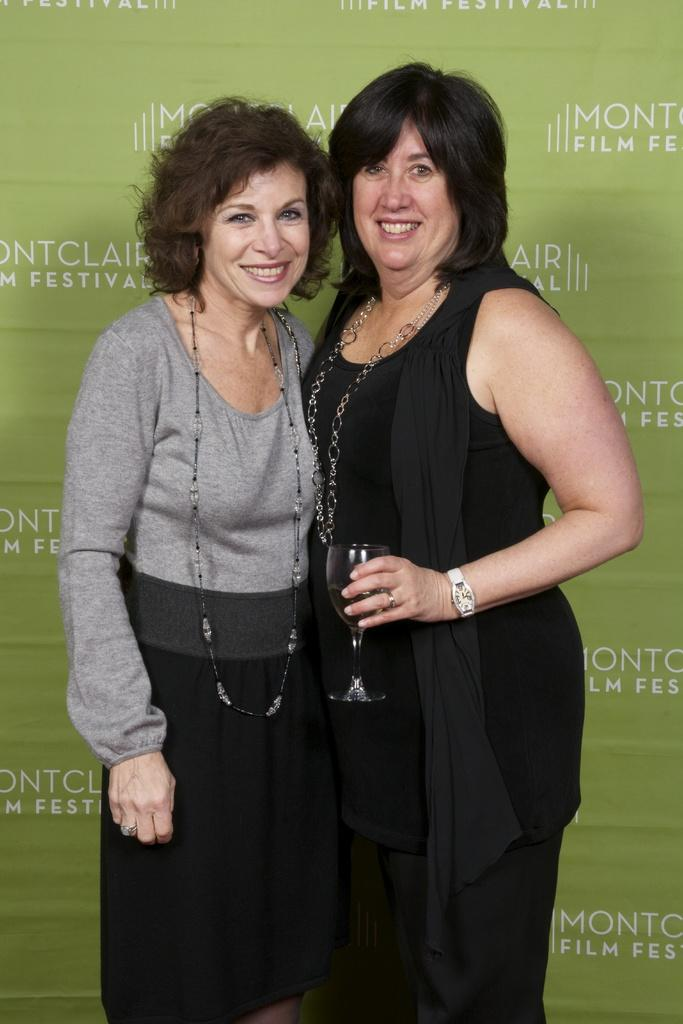How many people are in the image? There are two persons in the image. What is one of the persons holding? One of the persons is holding a glass. What type of beam is being used by the police in the image? There is no beam or police present in the image; it only features two persons, one of whom is holding a glass. 